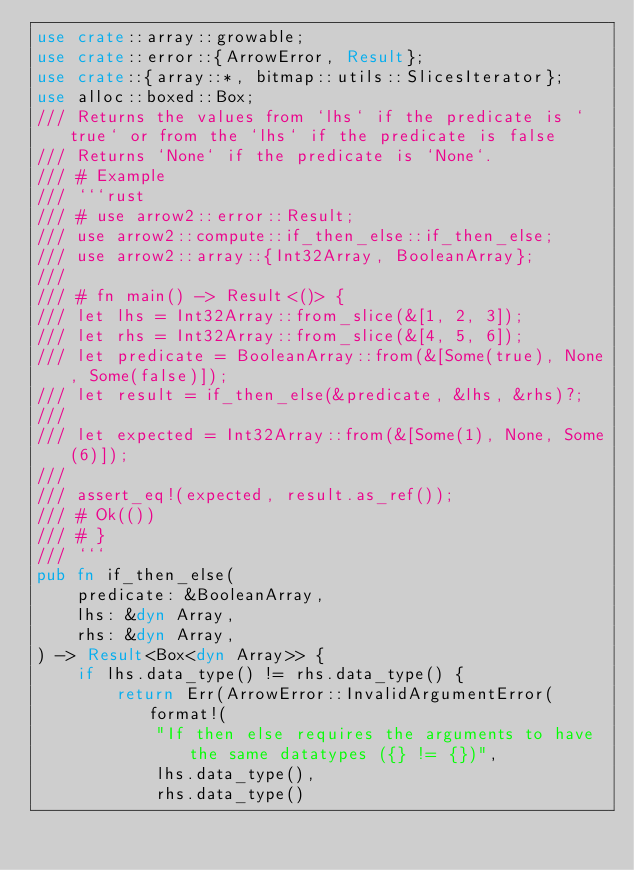Convert code to text. <code><loc_0><loc_0><loc_500><loc_500><_Rust_>use crate::array::growable;
use crate::error::{ArrowError, Result};
use crate::{array::*, bitmap::utils::SlicesIterator};
use alloc::boxed::Box;
/// Returns the values from `lhs` if the predicate is `true` or from the `lhs` if the predicate is false
/// Returns `None` if the predicate is `None`.
/// # Example
/// ```rust
/// # use arrow2::error::Result;
/// use arrow2::compute::if_then_else::if_then_else;
/// use arrow2::array::{Int32Array, BooleanArray};
///
/// # fn main() -> Result<()> {
/// let lhs = Int32Array::from_slice(&[1, 2, 3]);
/// let rhs = Int32Array::from_slice(&[4, 5, 6]);
/// let predicate = BooleanArray::from(&[Some(true), None, Some(false)]);
/// let result = if_then_else(&predicate, &lhs, &rhs)?;
///
/// let expected = Int32Array::from(&[Some(1), None, Some(6)]);
///
/// assert_eq!(expected, result.as_ref());
/// # Ok(())
/// # }
/// ```
pub fn if_then_else(
    predicate: &BooleanArray,
    lhs: &dyn Array,
    rhs: &dyn Array,
) -> Result<Box<dyn Array>> {
    if lhs.data_type() != rhs.data_type() {
        return Err(ArrowError::InvalidArgumentError(format!(
            "If then else requires the arguments to have the same datatypes ({} != {})",
            lhs.data_type(),
            rhs.data_type()</code> 